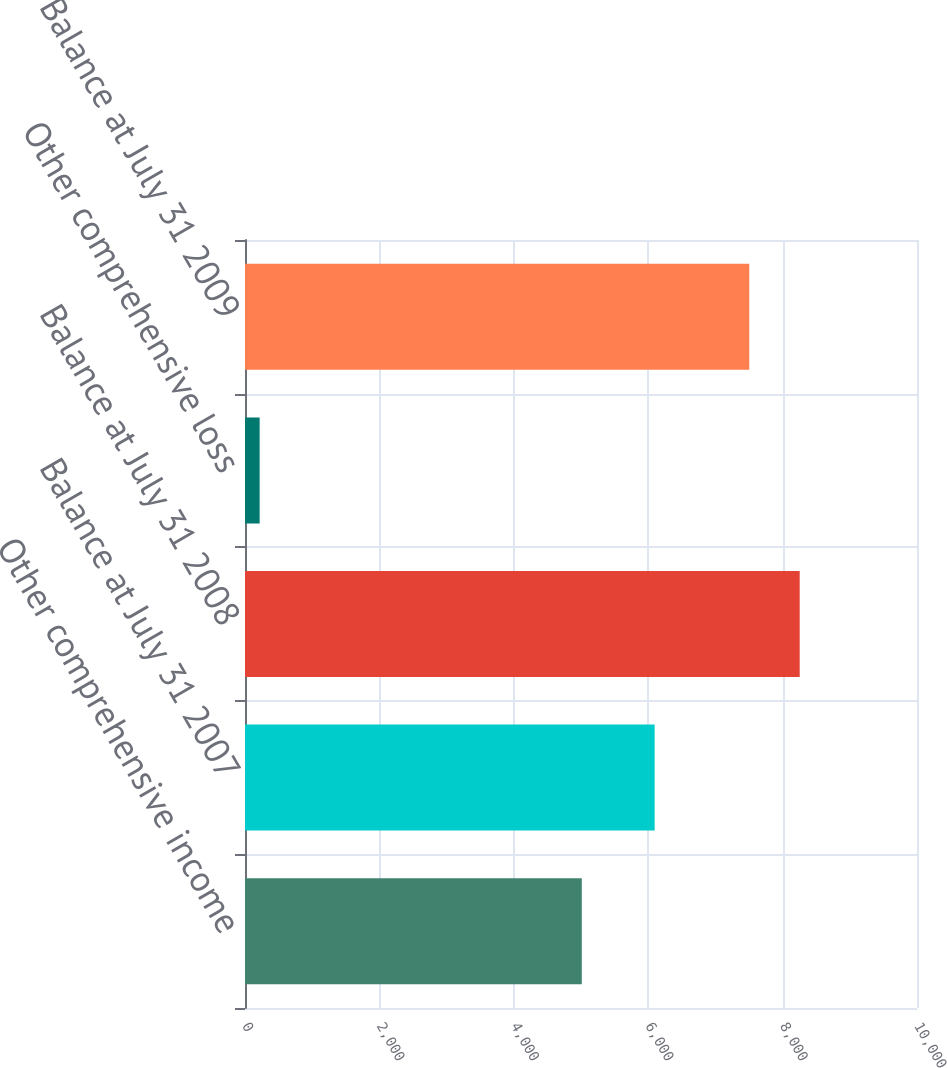<chart> <loc_0><loc_0><loc_500><loc_500><bar_chart><fcel>Other comprehensive income<fcel>Balance at July 31 2007<fcel>Balance at July 31 2008<fcel>Other comprehensive loss<fcel>Balance at July 31 2009<nl><fcel>5012<fcel>6096<fcel>8254.4<fcel>218<fcel>7504<nl></chart> 